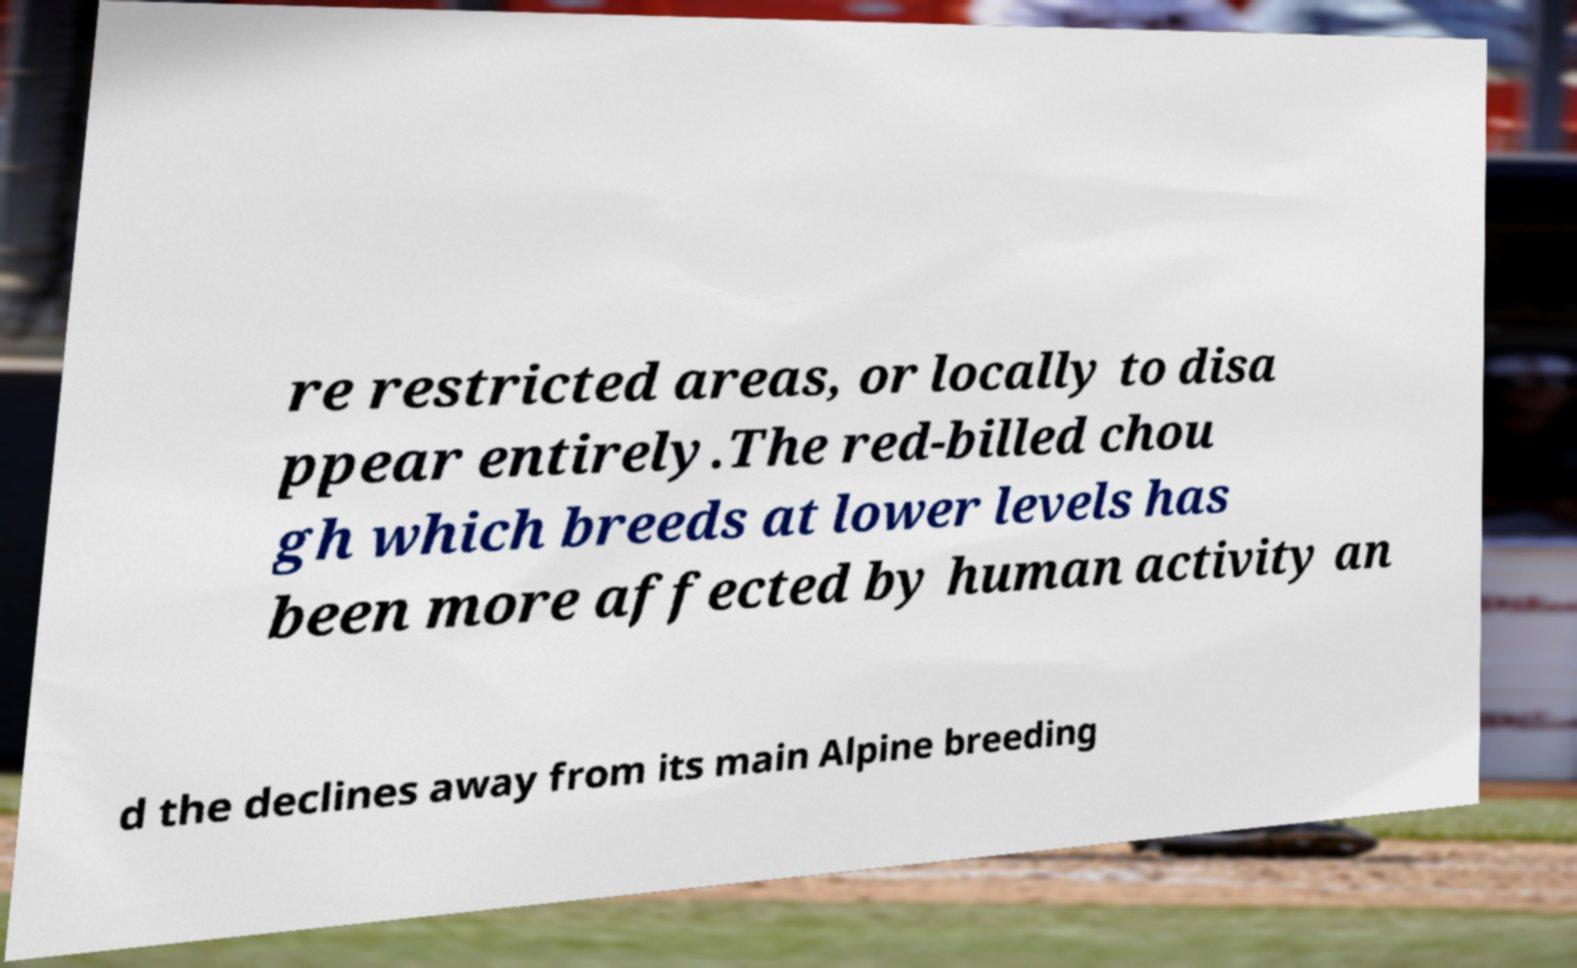Please read and relay the text visible in this image. What does it say? re restricted areas, or locally to disa ppear entirely.The red-billed chou gh which breeds at lower levels has been more affected by human activity an d the declines away from its main Alpine breeding 